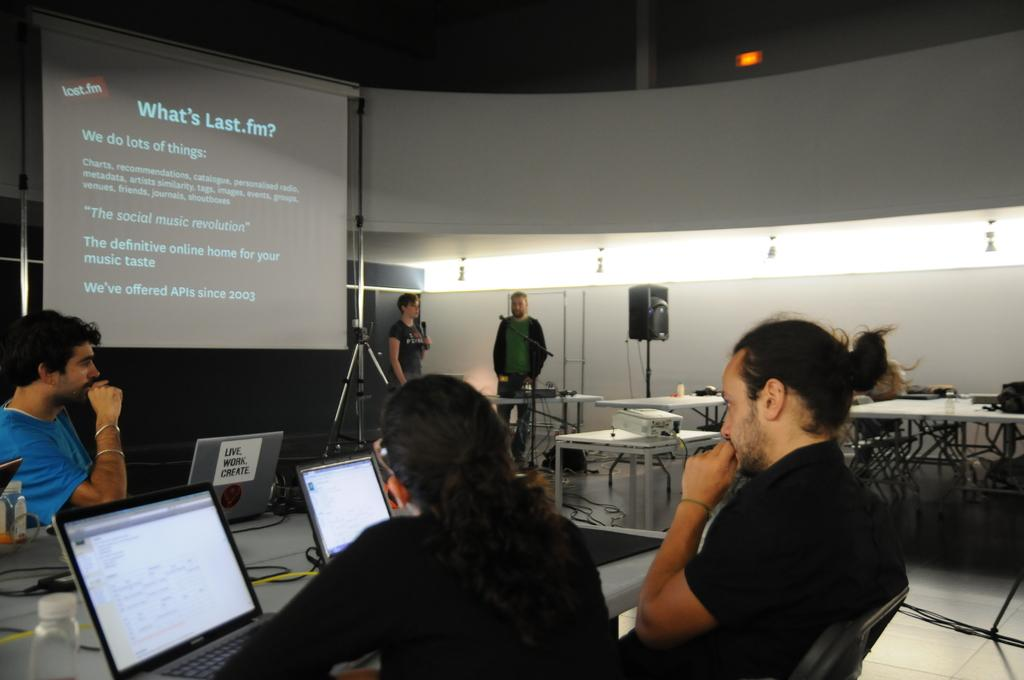Provide a one-sentence caption for the provided image. Classroom where a presentation is being held and the slide titled What's Last .fm? being projected. 